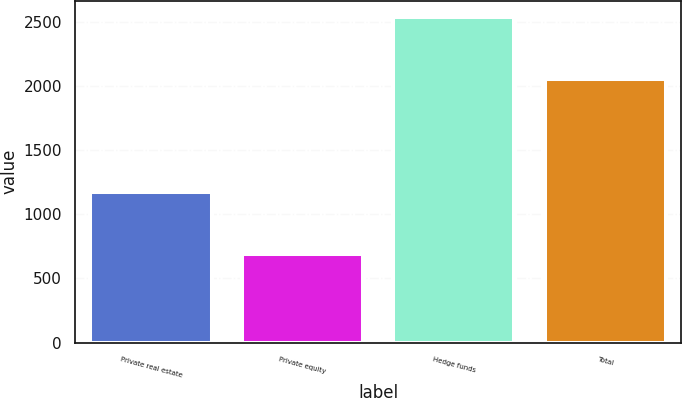Convert chart to OTSL. <chart><loc_0><loc_0><loc_500><loc_500><bar_chart><fcel>Private real estate<fcel>Private equity<fcel>Hedge funds<fcel>Total<nl><fcel>1172<fcel>687<fcel>2538<fcel>2053<nl></chart> 